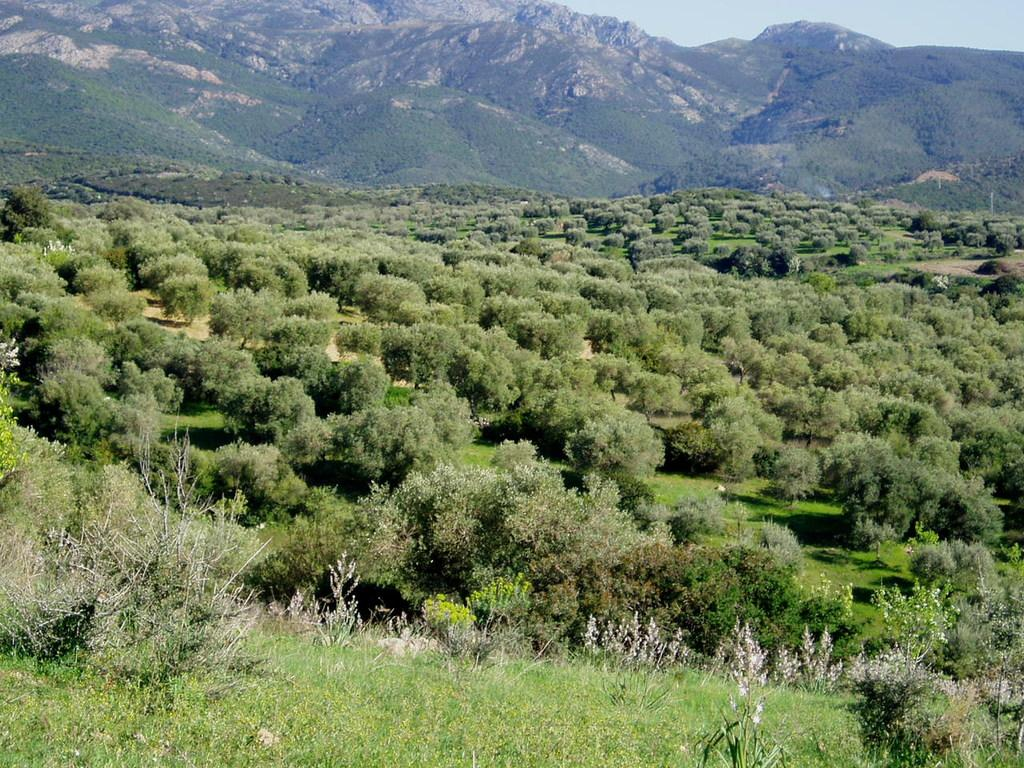What type of natural elements can be seen in the image? There are trees and hills in the image. What part of the sky is visible in the image? The sky is visible in the top right corner of the image. What historical event is being discussed by the judge in the image? There is no judge or historical event present in the image; it features trees and hills with a visible sky. 